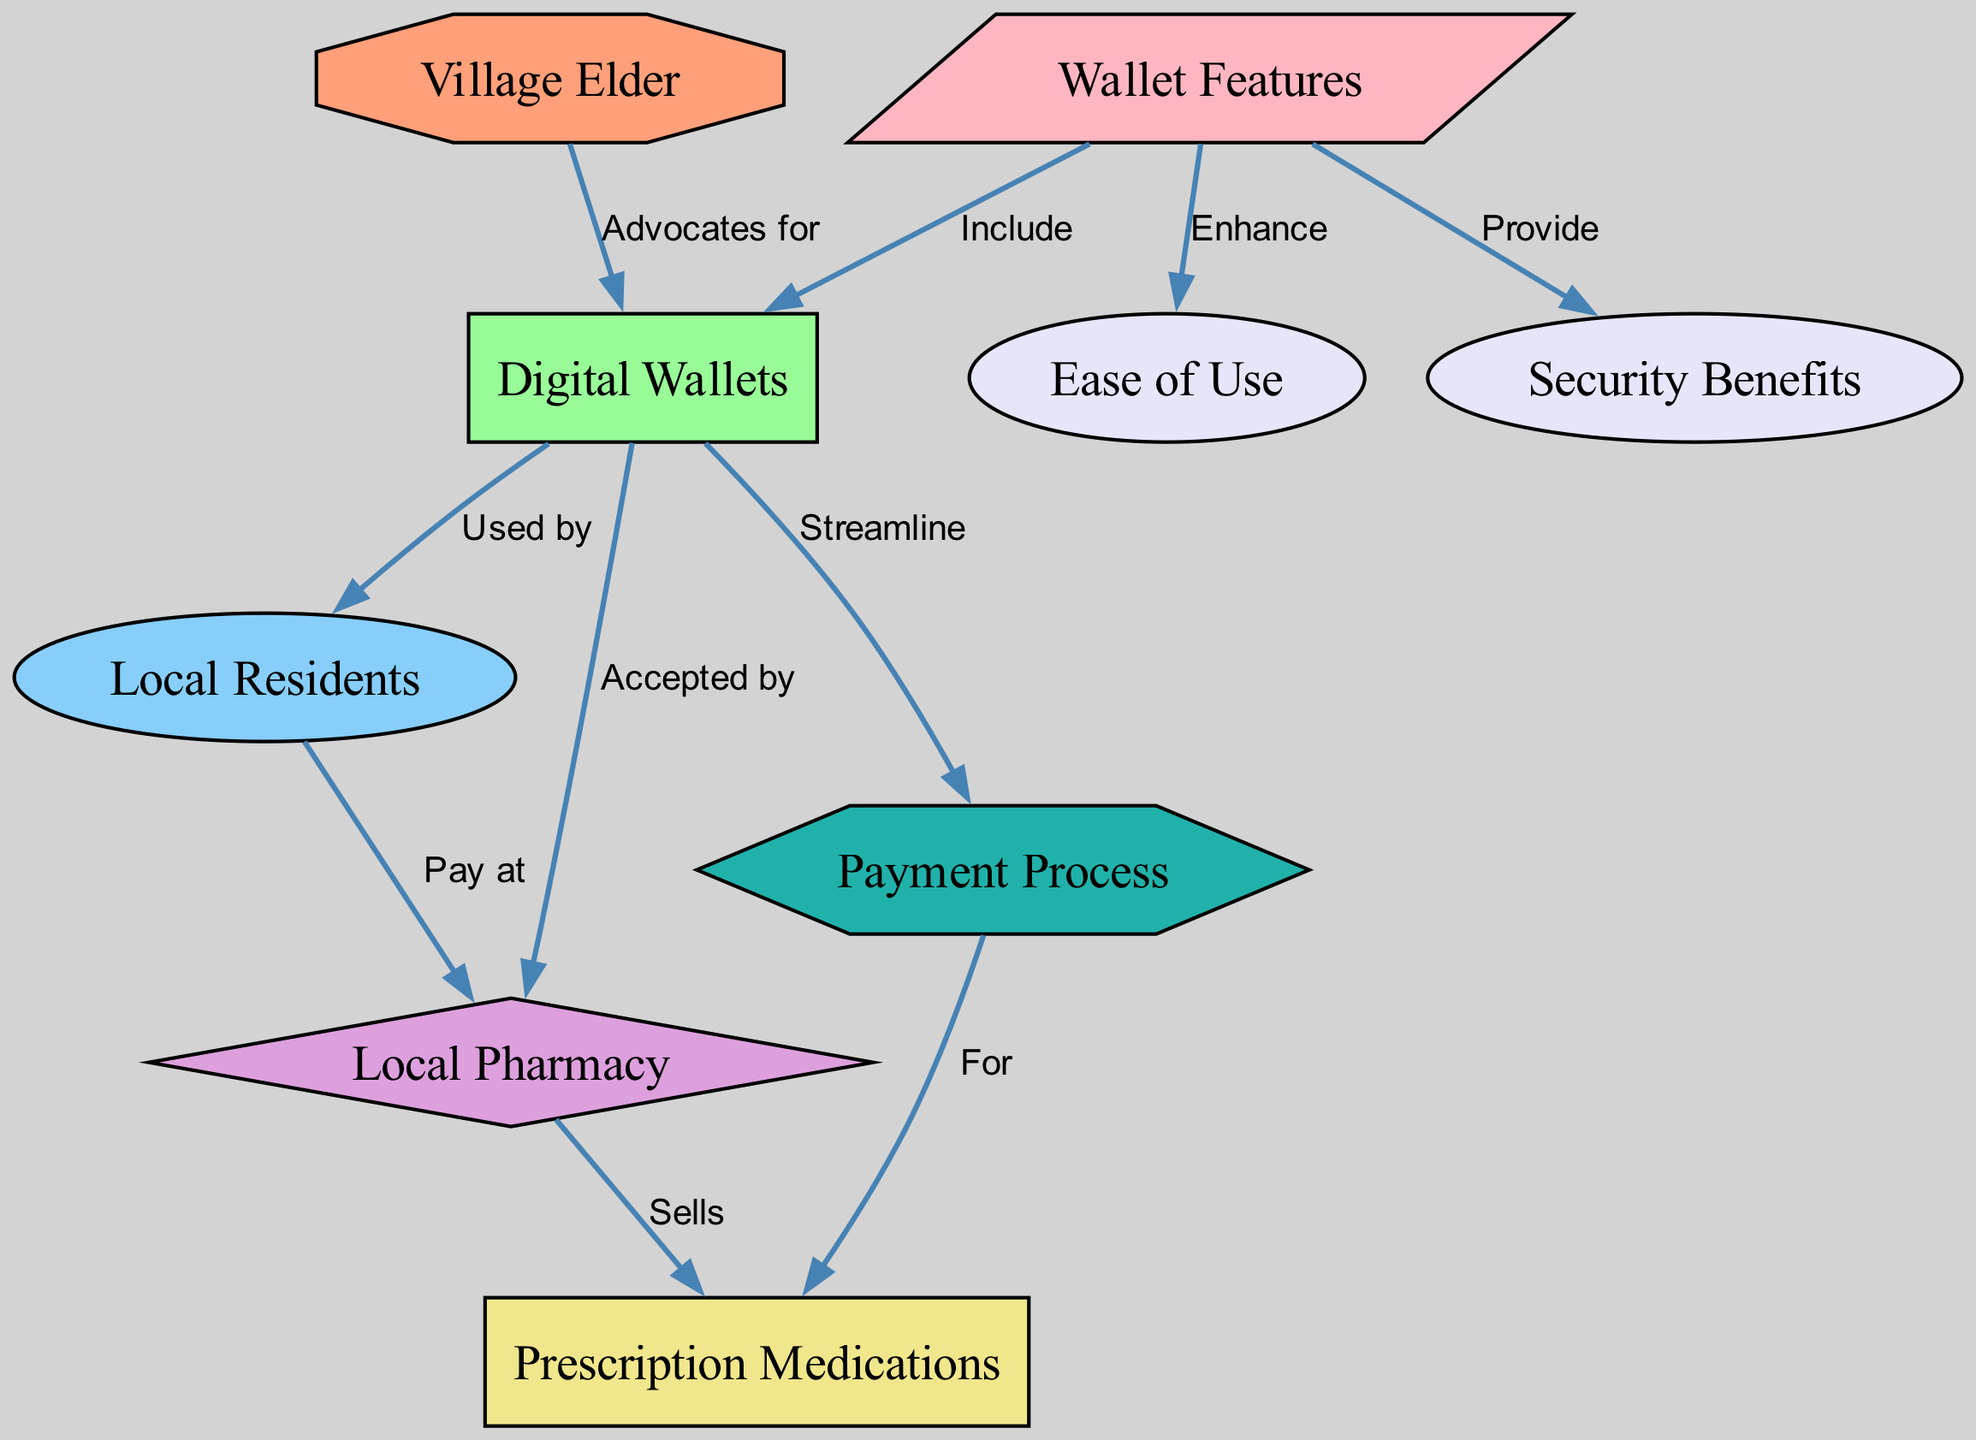What does the village elder advocate for? The diagram indicates that the village elder advocates for digital wallets. This is shown as a direct edge from the village elder node to the digital wallets node, labeled "Advocates for."
Answer: Digital wallets Who uses digital wallets? The diagram illustrates that local residents use digital wallets, depicted as an edge from the digital wallets node to the residents node labeled "Used by."
Answer: Local residents How many nodes are present in the diagram? By counting each unique node in the diagram, we see there are a total of 9 nodes listed.
Answer: 9 What feature of digital wallets enhances ease of use? The diagram shows a connection from wallet features to ease of use, labeled "Enhance." This implies that wallet features contribute to the ease of use of the digital wallets.
Answer: Wallet features What type of payments do residents make at the pharmacy? According to the diagram, the residents pay at the pharmacy using digital wallets. This can be seen in the edge from the residents node to the pharmacy node labeled "Pay at."
Answer: Digital wallets What process do digital wallets streamline? The diagram shows that digital wallets streamline the payment process, as indicated by the edge from the digital wallets node to the payment process node labeled "Streamline."
Answer: Payment process What are the security benefits provided by wallet features? Although the diagram does not explicitly list the security benefits, it indicates that wallet features provide security benefits through the labeled connection from wallet features to security benefits. Thus, we can infer that wallet features are responsible for enhancing security in digital payments.
Answer: Security benefits What does the pharmacy sell? In the diagram, there is an edge from the pharmacy node to the prescription medications node labeled "Sells," indicating that the pharmacy's primary sale item is prescription medications.
Answer: Prescription medications What nodes are linked by the payment process? The payment process is linked to the prescription medications node, as indicated by the edge from the payment process node to the prescription medications node labeled "For." This relationship demonstrates the purpose of the payment process.
Answer: Prescription medications 